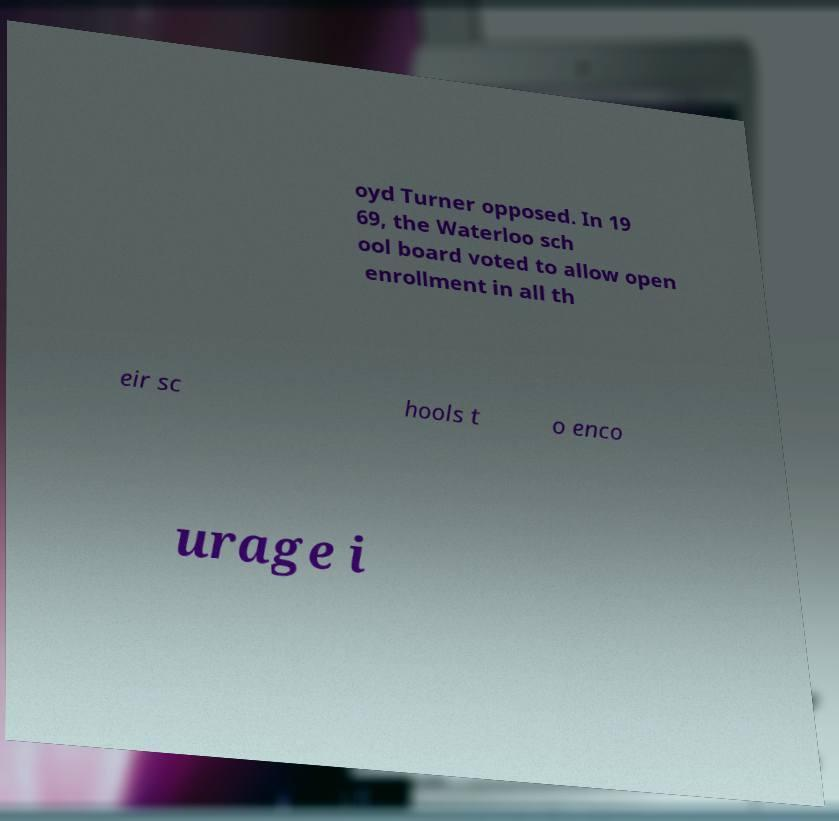I need the written content from this picture converted into text. Can you do that? oyd Turner opposed. In 19 69, the Waterloo sch ool board voted to allow open enrollment in all th eir sc hools t o enco urage i 